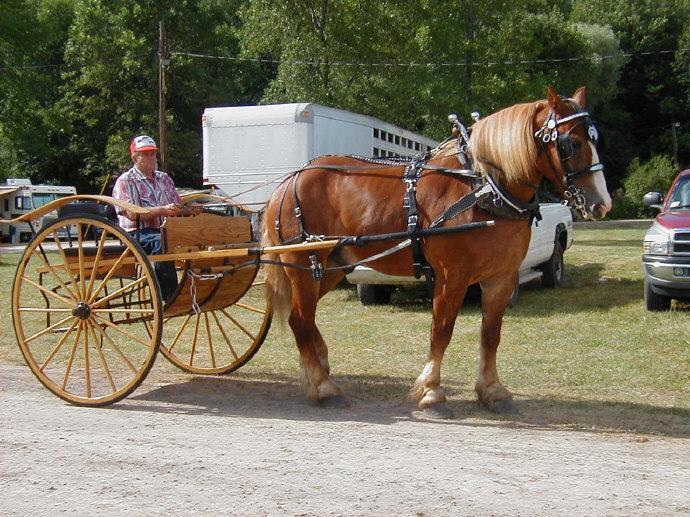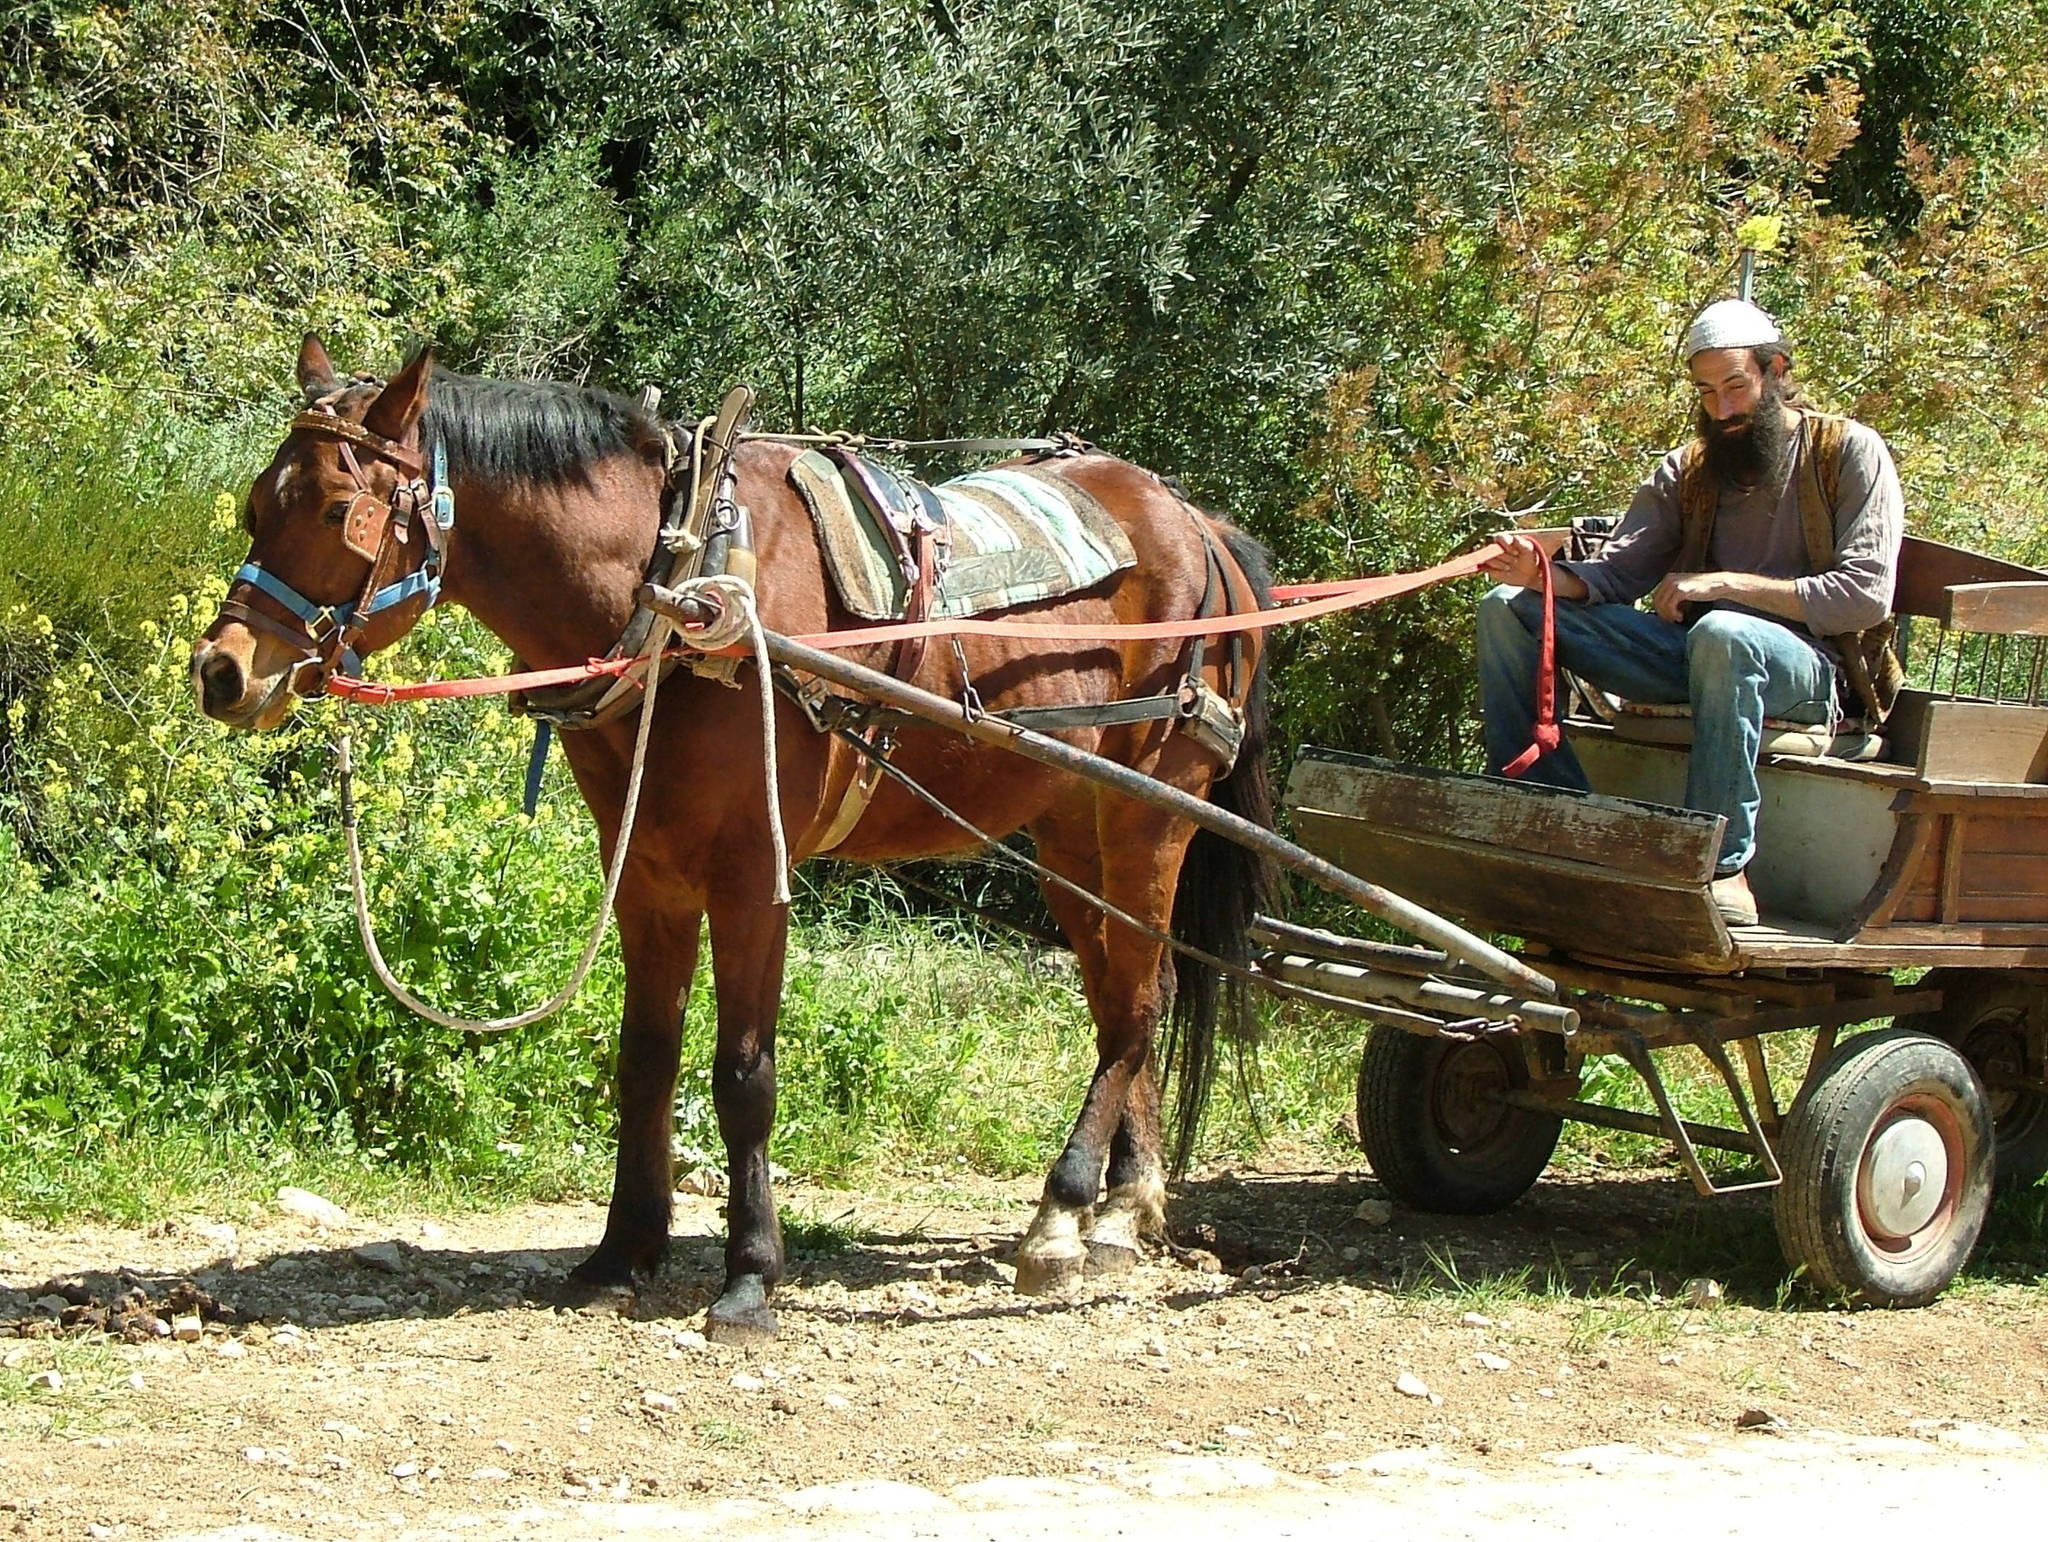The first image is the image on the left, the second image is the image on the right. Analyze the images presented: Is the assertion "At least one horse is black." valid? Answer yes or no. No. 